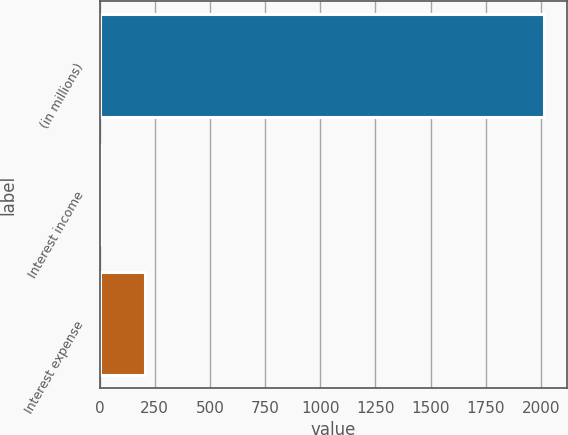Convert chart to OTSL. <chart><loc_0><loc_0><loc_500><loc_500><bar_chart><fcel>(in millions)<fcel>Interest income<fcel>Interest expense<nl><fcel>2015<fcel>4<fcel>205.1<nl></chart> 